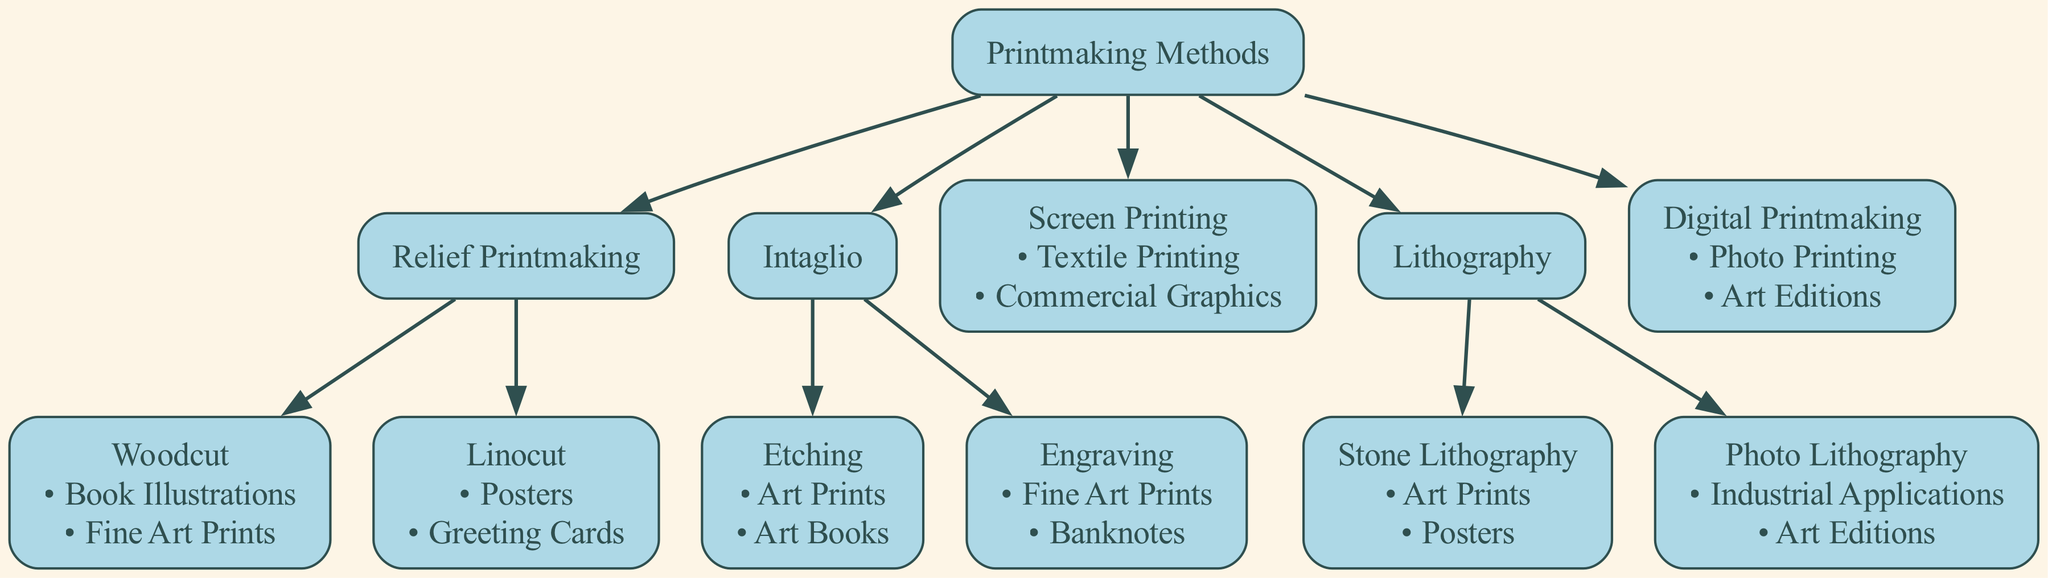What are the two main branches of the Printmaking Methods? The diagram shows two main branches under the Printmaking Methods: Relief Printmaking and Intaglio. These are the first level of subcategories under the root node.
Answer: Relief Printmaking, Intaglio How many applications does Woodcut have? According to the diagram, Woodcut has two applications listed: Book Illustrations and Fine Art Prints. Each application is noted directly beneath the Woodcut node.
Answer: 2 What method is used for Textile Printing? Looking at the diagram, Screen Printing is identified as having Textile Printing as one of its applications. This is explicitly stated under the Screen Printing node.
Answer: Screen Printing Which printmaking method has the most applications listed? Analyzing the diagram, both Woodcut and Intaglio (Engraving and Etching) have two applications, while others like Screen Printing and Digital Printmaking have fewer. Thus, the methods sharing maximum applications are Woodcut and Intaglio.
Answer: Woodcut, Intaglio How many children does Lithography have? In the diagram, Lithography has two children nodes: Stone Lithography and Photo Lithography. Each is represented as subcategories under Lithography.
Answer: 2 What are the main applications for Engraving? The diagram provides two specific applications listed for Engraving: Fine Art Prints and Banknotes. This directly relates to the applications depicted in the Engraving child node.
Answer: Fine Art Prints, Banknotes What is the relationship between Digital Printmaking and Photo Printing? Digital Printmaking is a type of printmaking method that has Photo Printing listed as one of its applications, indicating that they are connected in the context of applications but Digital Printmaking is the parent node.
Answer: Parent-child relationship Which method is utilized for Industrial Applications? The diagram specifies that Photo Lithography is associated with Industrial Applications among its listed applications, illustrating the unique application of this specific method.
Answer: Photo Lithography What node directly connects to Linocut? The node that directly connects to Linocut is Relief Printmaking, as Linocut is one of the children of the Relief Printmaking node within the diagram structure.
Answer: Relief Printmaking 